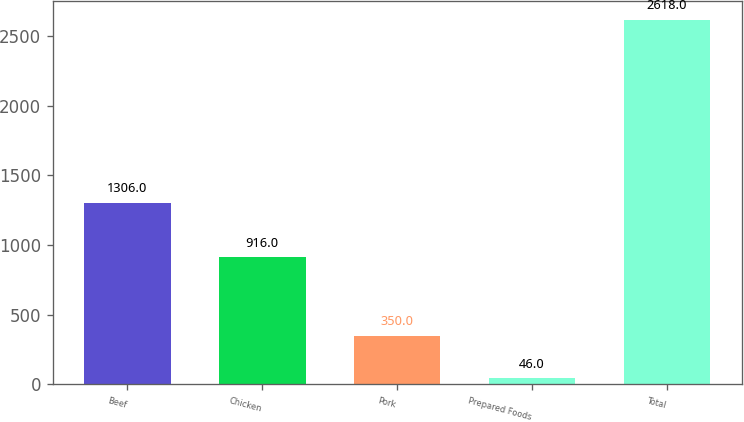Convert chart. <chart><loc_0><loc_0><loc_500><loc_500><bar_chart><fcel>Beef<fcel>Chicken<fcel>Pork<fcel>Prepared Foods<fcel>Total<nl><fcel>1306<fcel>916<fcel>350<fcel>46<fcel>2618<nl></chart> 